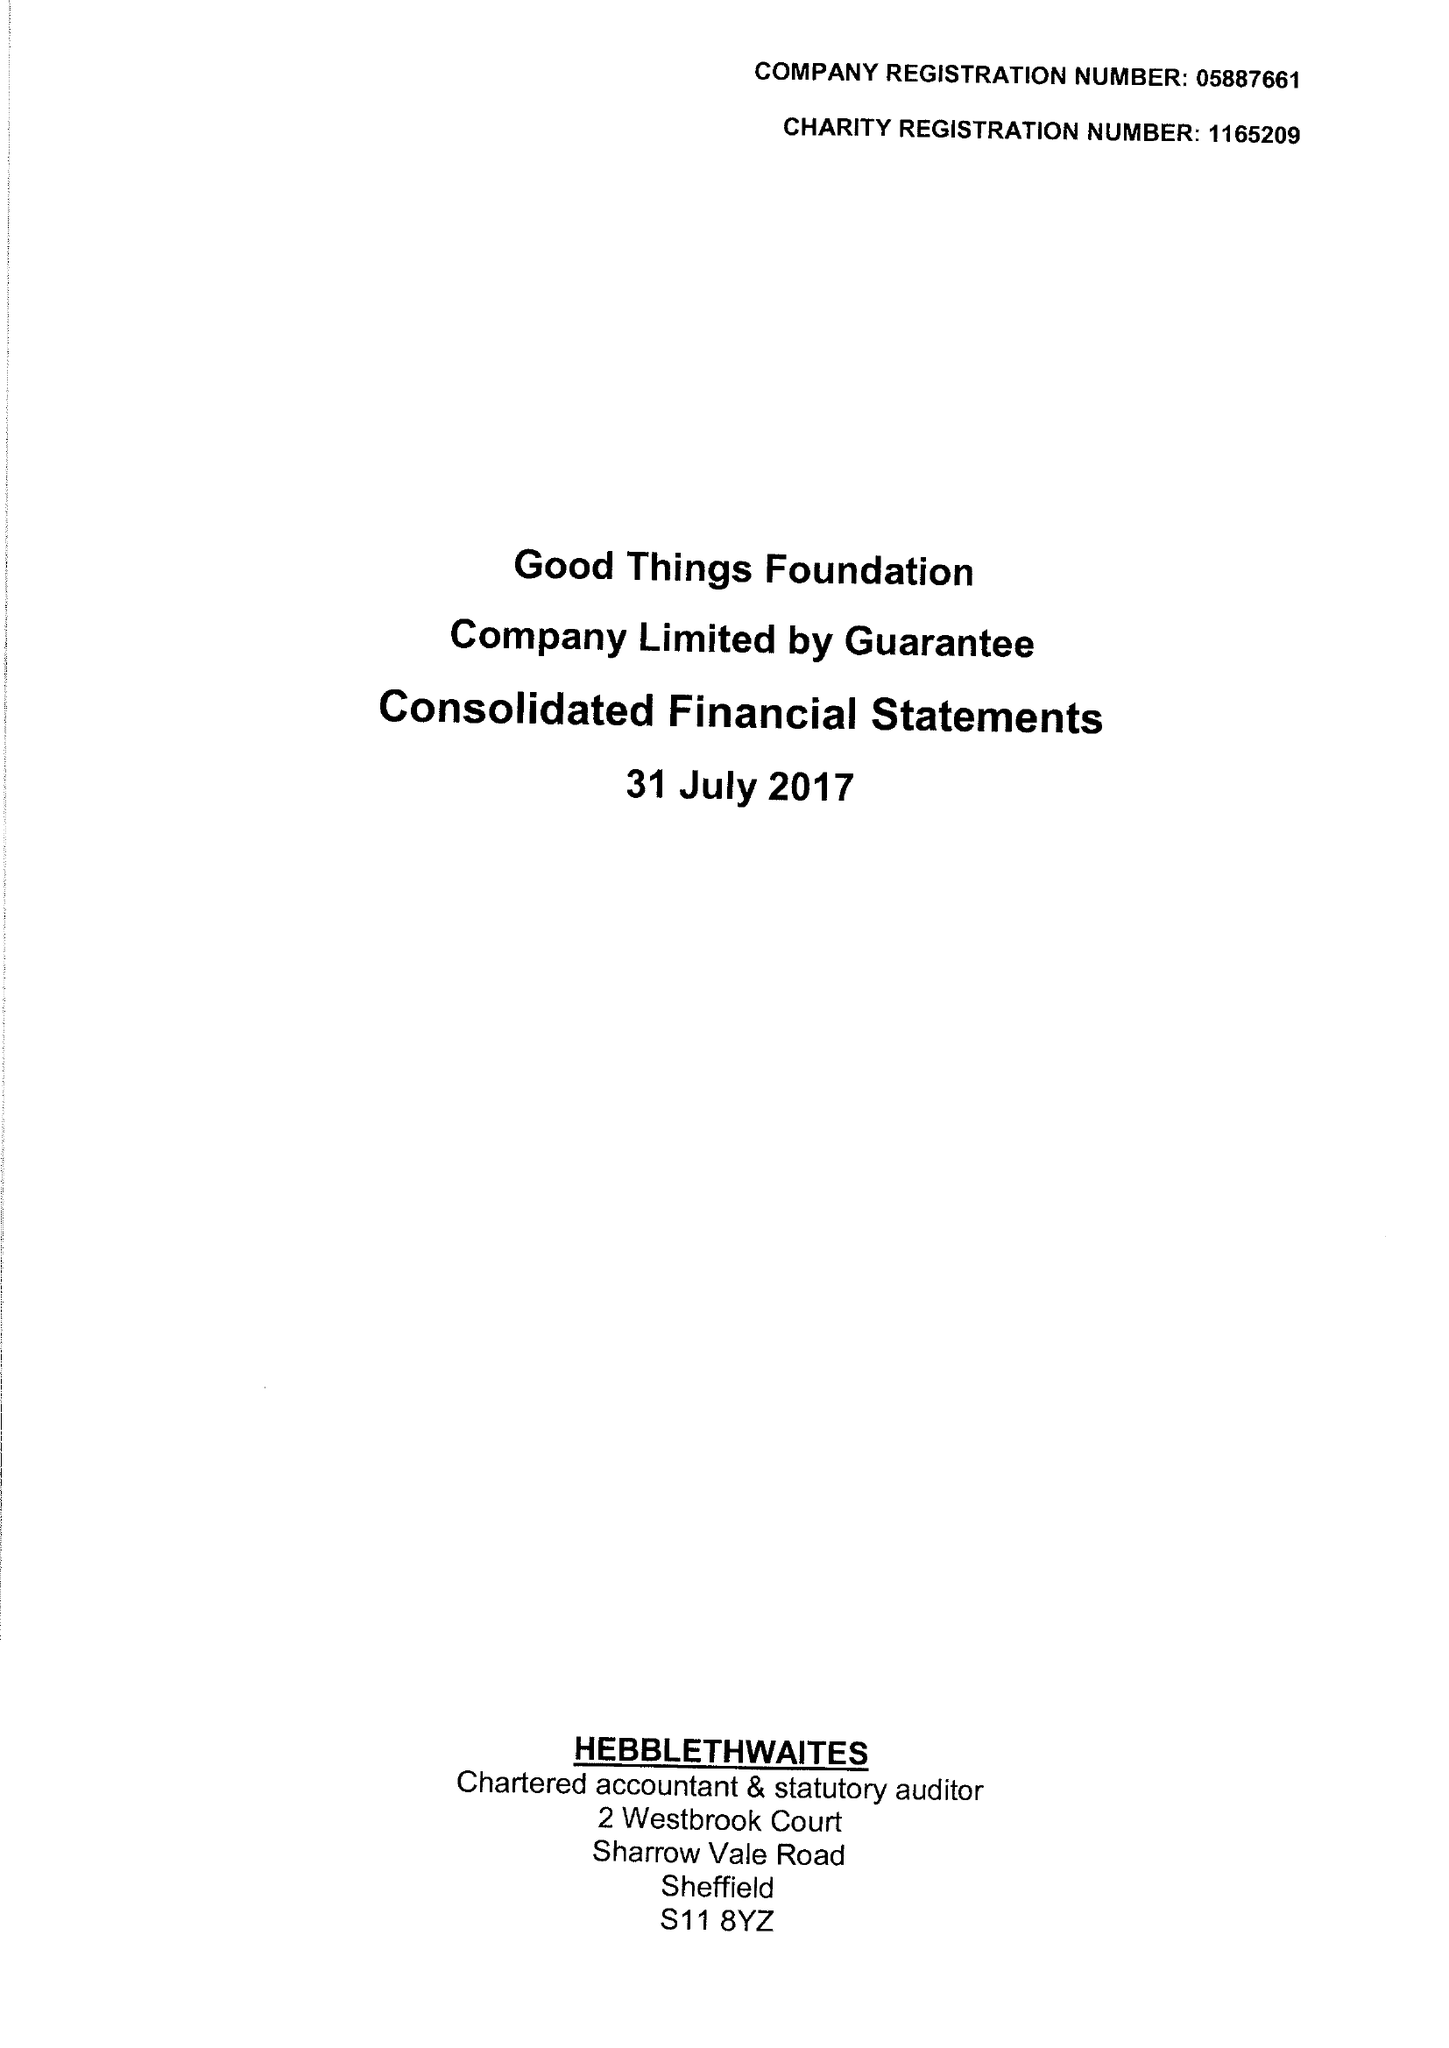What is the value for the address__post_town?
Answer the question using a single word or phrase. SHEFFIELD 